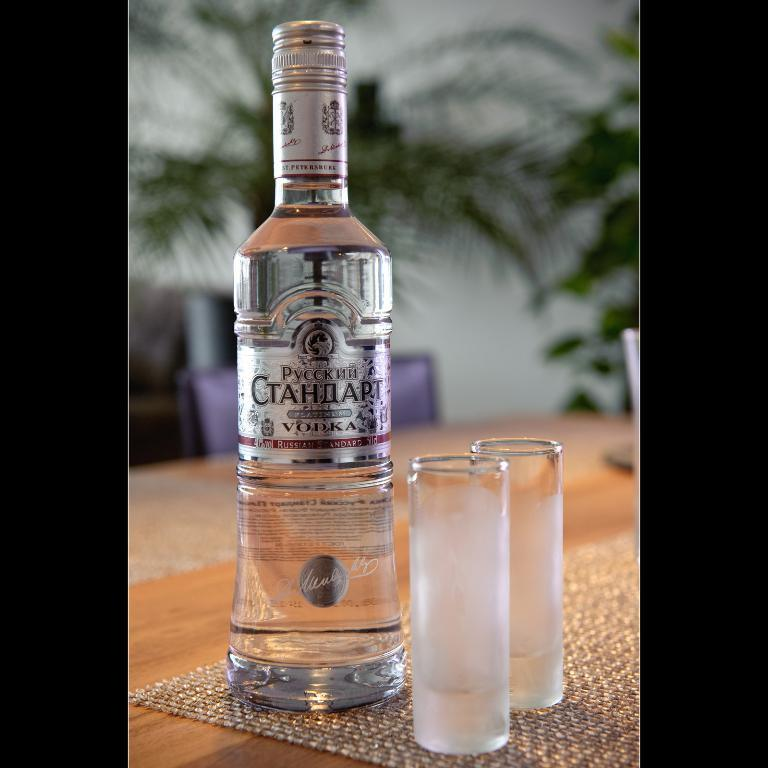<image>
Present a compact description of the photo's key features. Two very narrow glasses sit next to a bottle of Pyccknn Vodka. 